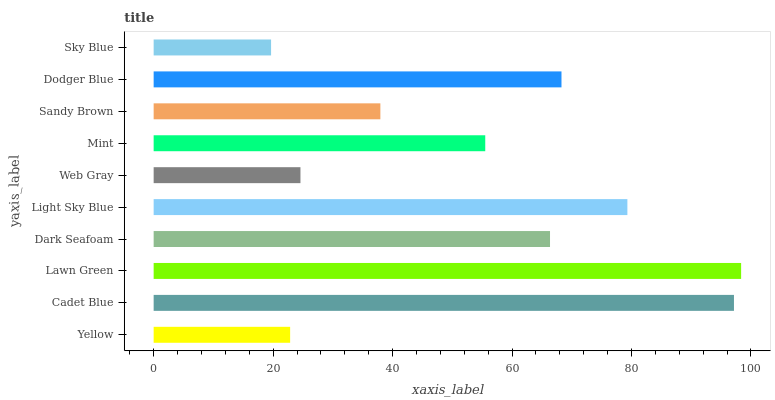Is Sky Blue the minimum?
Answer yes or no. Yes. Is Lawn Green the maximum?
Answer yes or no. Yes. Is Cadet Blue the minimum?
Answer yes or no. No. Is Cadet Blue the maximum?
Answer yes or no. No. Is Cadet Blue greater than Yellow?
Answer yes or no. Yes. Is Yellow less than Cadet Blue?
Answer yes or no. Yes. Is Yellow greater than Cadet Blue?
Answer yes or no. No. Is Cadet Blue less than Yellow?
Answer yes or no. No. Is Dark Seafoam the high median?
Answer yes or no. Yes. Is Mint the low median?
Answer yes or no. Yes. Is Lawn Green the high median?
Answer yes or no. No. Is Lawn Green the low median?
Answer yes or no. No. 